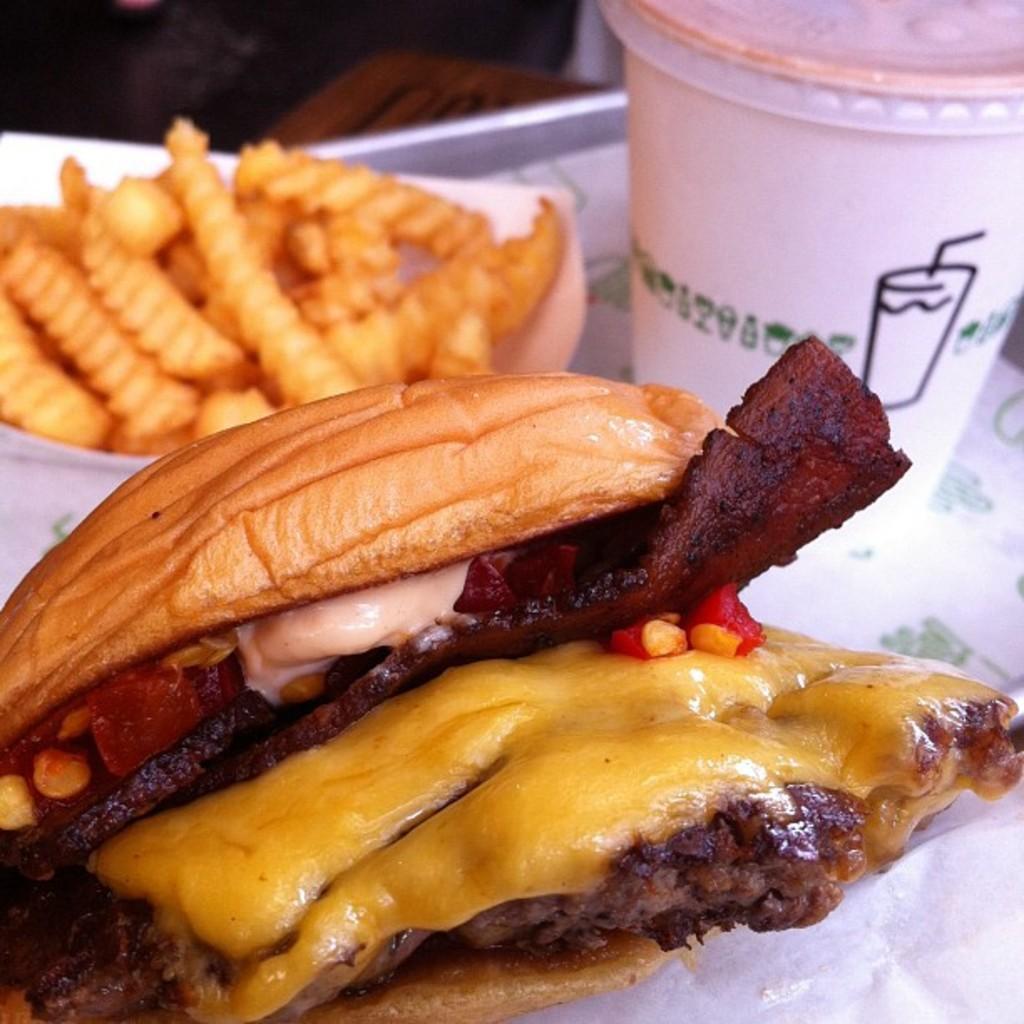Could you give a brief overview of what you see in this image? In the image in the center we can see one table. On the table,there is a plate,tissue paper,glass,bowl and some food items. 